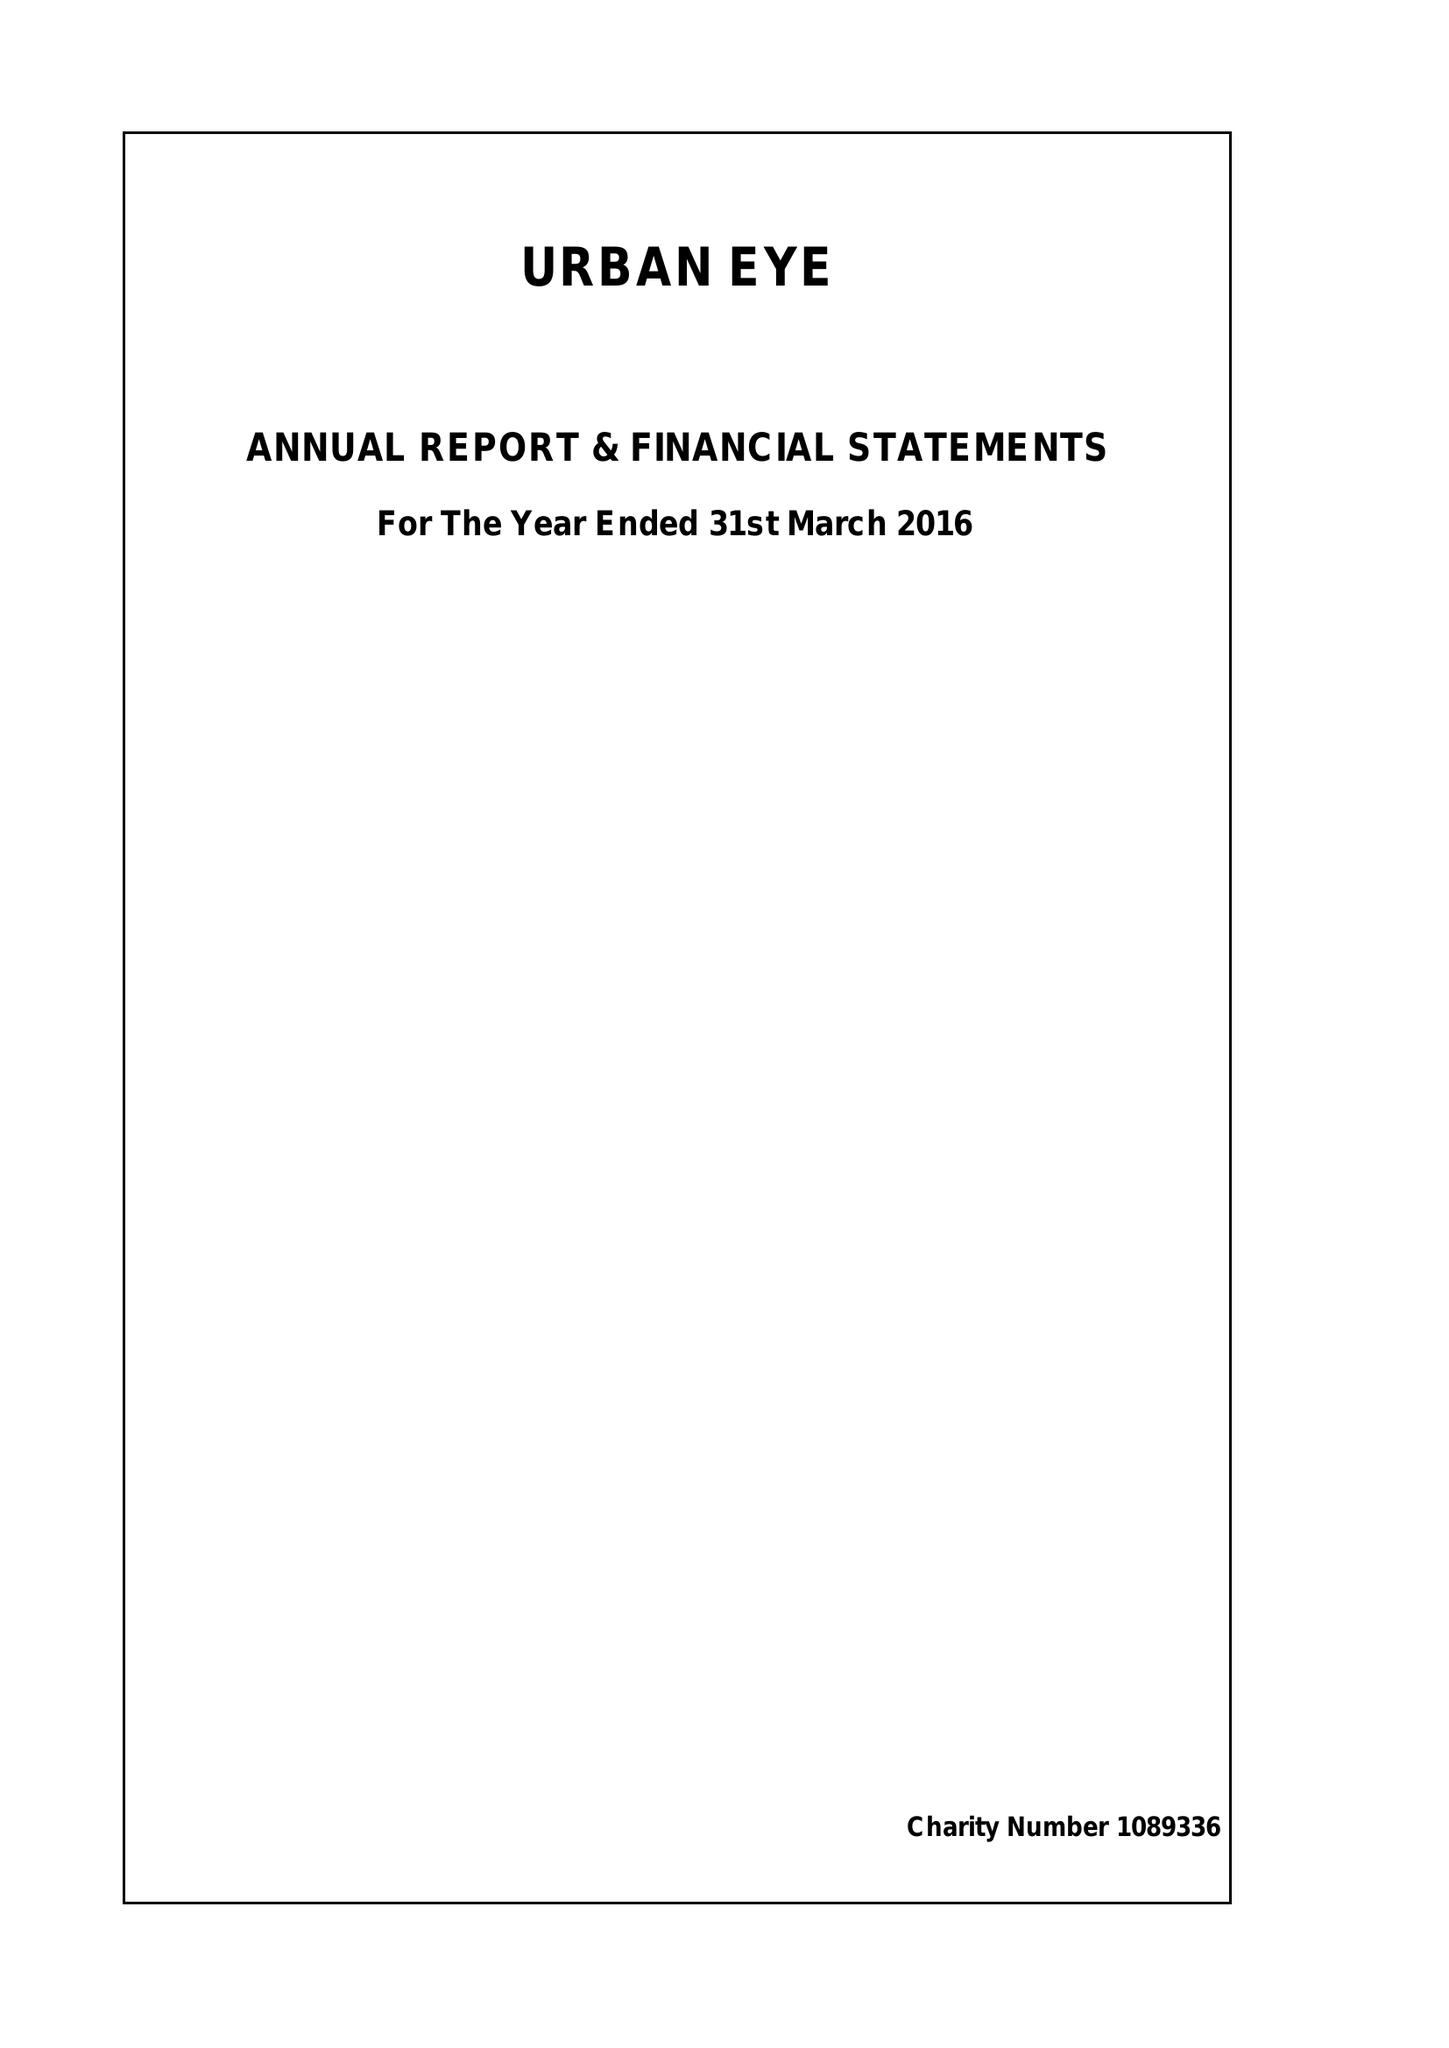What is the value for the report_date?
Answer the question using a single word or phrase. 2016-03-31 